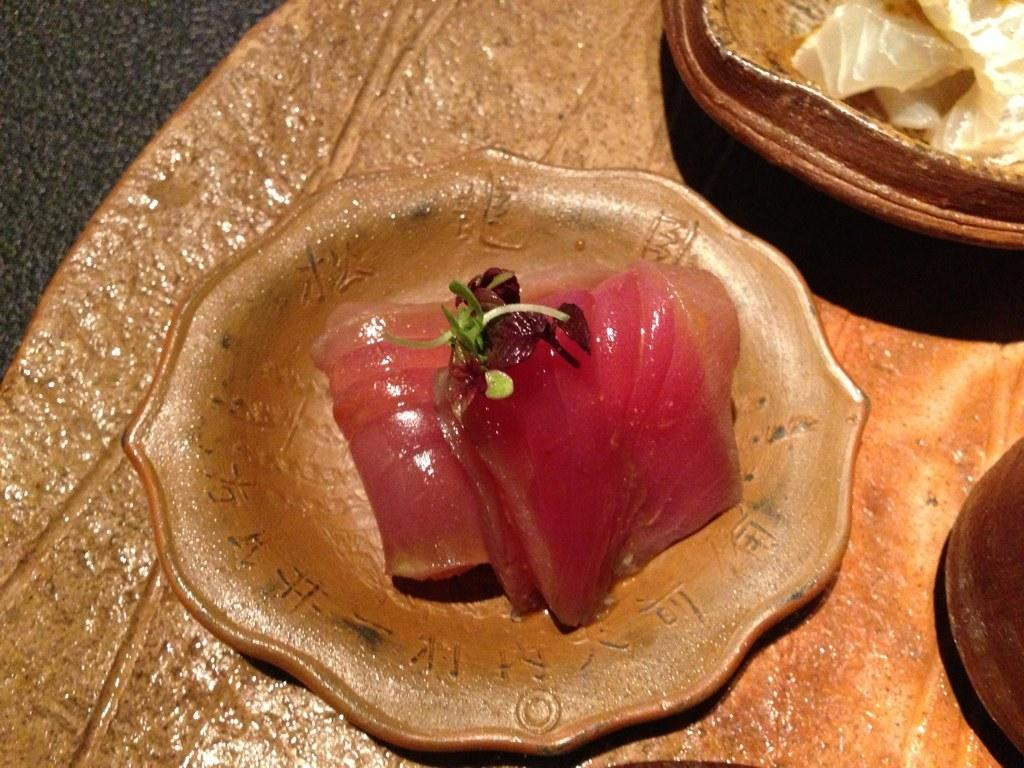What is present on the plate in the image? The facts do not specify what is on the plate. What is in the bowl in the image? The bowl contains food items. Are the plate and bowl connected or part of a larger object? The bowl and plate may be part of a tray. What can be seen on the right side of the image? There is an object on the right side of the image. How many sheep are visible in the image? There are no sheep present in the image. 